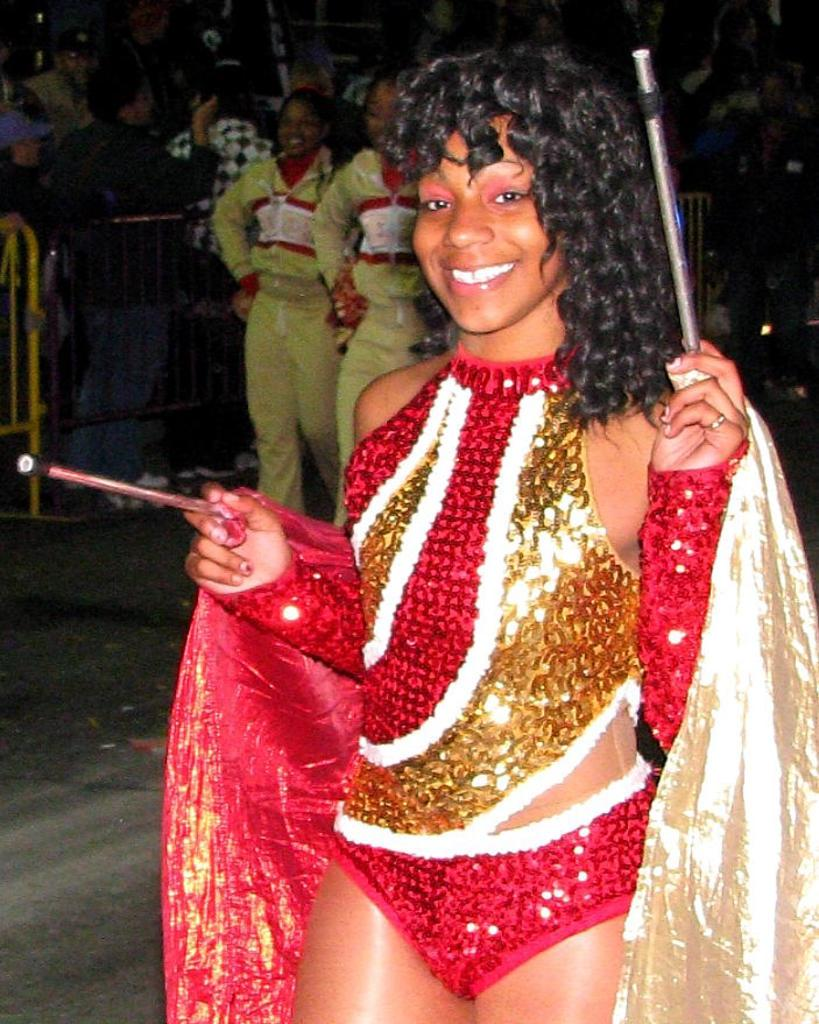Who is the main subject in the image? There is a woman in the image. What is the woman holding in her hands? The woman is holding two sticks with both hands. Can you describe the background of the image? The background of the image is dark in color. Are there any other people visible in the image? Yes, there are other persons in the background of the image. What type of work is the woman doing with the tray in the image? There is no tray present in the image, so the woman is not doing any work with a tray. 